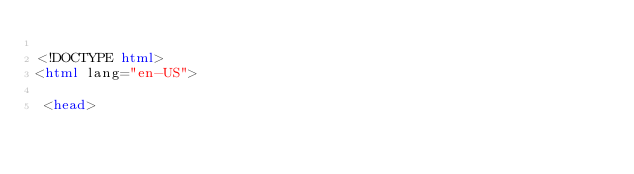<code> <loc_0><loc_0><loc_500><loc_500><_HTML_>
<!DOCTYPE html>
<html lang="en-US">

 <head></code> 